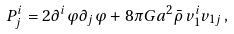<formula> <loc_0><loc_0><loc_500><loc_500>P ^ { i } _ { j } = 2 \partial ^ { i } \varphi \partial _ { j } \varphi + 8 \pi G a ^ { 2 } \bar { \rho } \, v ^ { i } _ { 1 } v _ { 1 j } \, ,</formula> 